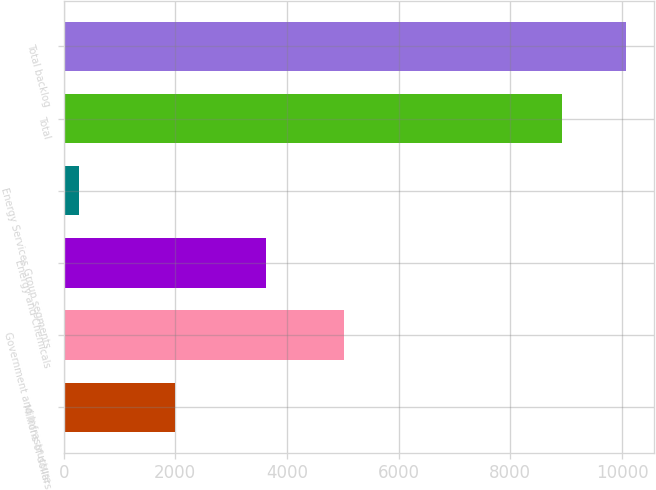<chart> <loc_0><loc_0><loc_500><loc_500><bar_chart><fcel>Millions of dollars<fcel>Government and Infrastructure<fcel>Energy and Chemicals<fcel>Energy Services Group segments<fcel>Total<fcel>Total backlog<nl><fcel>2003<fcel>5025<fcel>3625<fcel>278<fcel>8928<fcel>10066<nl></chart> 